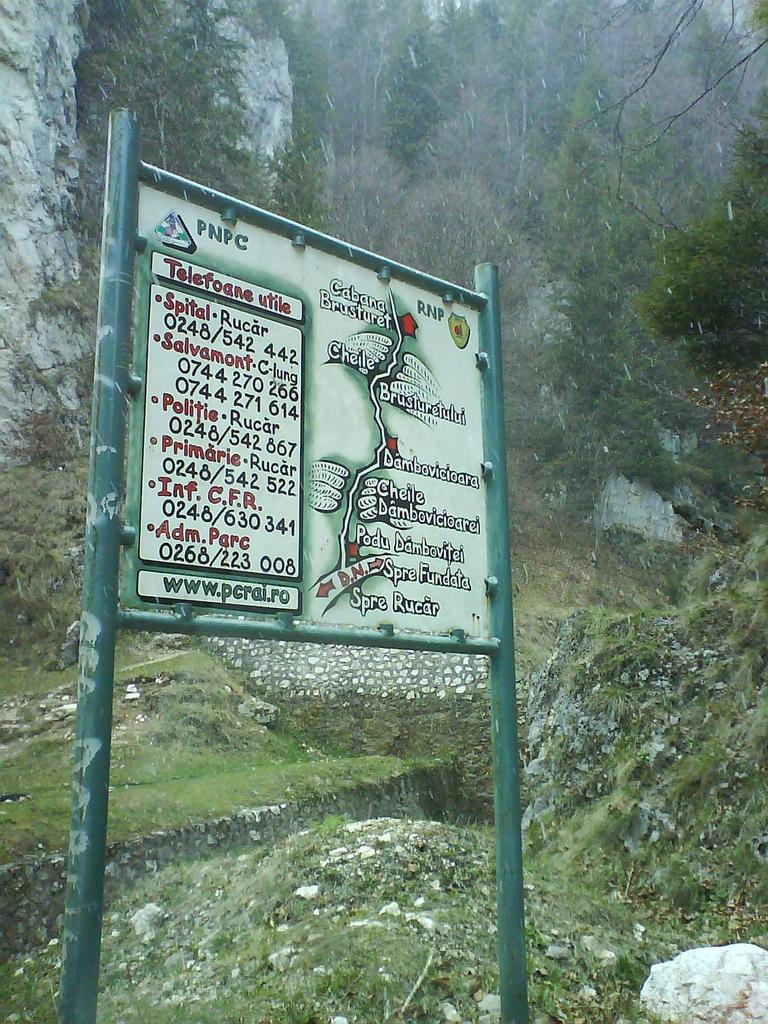What is the main object in the image? There is a signboard in the image. What can be seen in the background of the image? There are trees and rocks in the background of the image. What type of rake is being used to maintain the view in the image? There is no rake present in the image, and the view is not being maintained by any tool or person. 